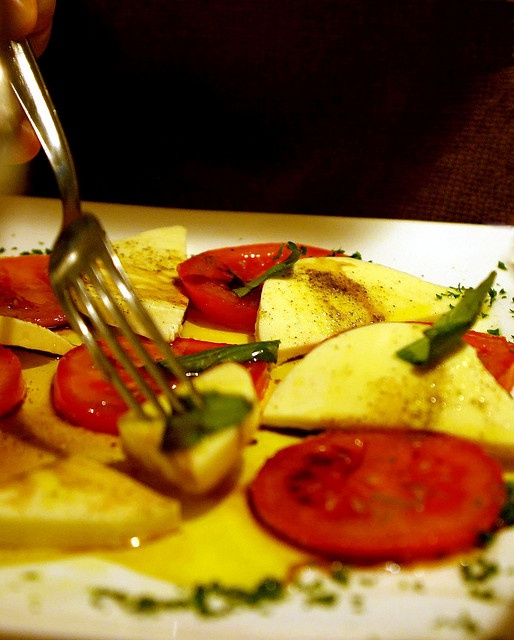Describe the objects in this image and their specific colors. I can see pizza in maroon, brown, orange, olive, and gold tones, people in black, maroon, and olive tones, apple in maroon, khaki, gold, and red tones, fork in maroon, olive, and black tones, and apple in maroon, orange, and gold tones in this image. 